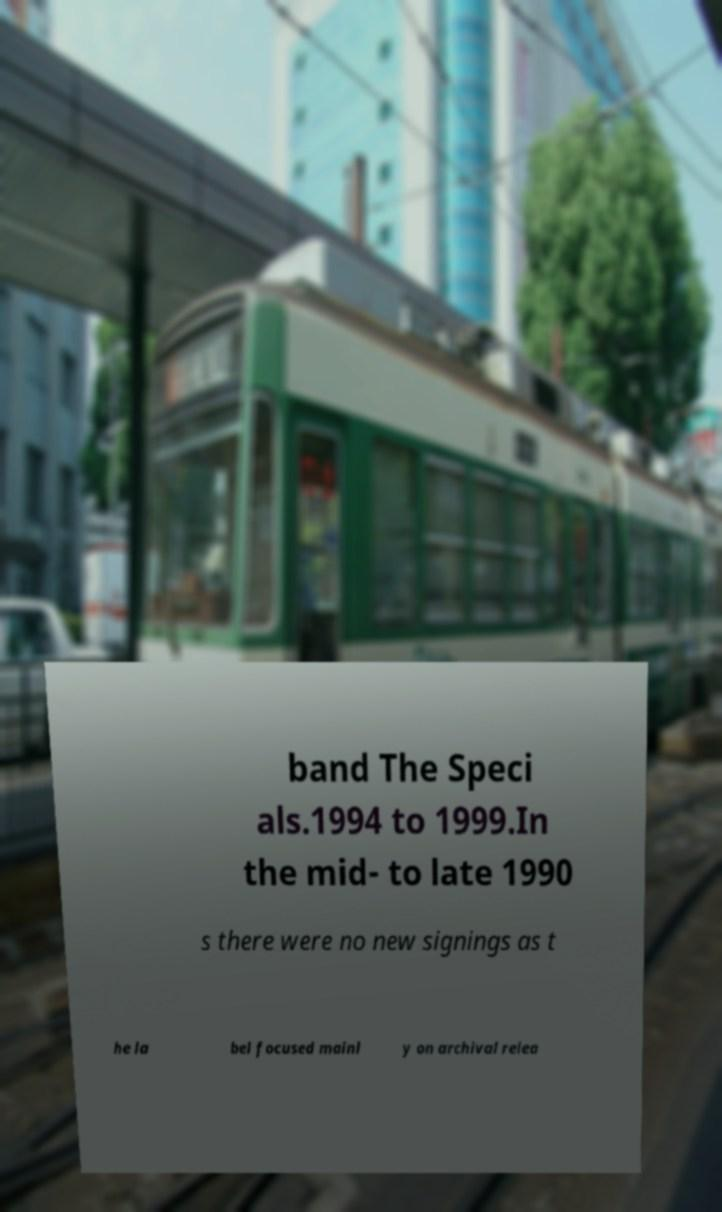Please identify and transcribe the text found in this image. band The Speci als.1994 to 1999.In the mid- to late 1990 s there were no new signings as t he la bel focused mainl y on archival relea 